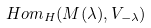Convert formula to latex. <formula><loc_0><loc_0><loc_500><loc_500>H o m _ { H } ( M ( \lambda ) , V _ { - \lambda } )</formula> 